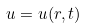<formula> <loc_0><loc_0><loc_500><loc_500>u = u ( r , t )</formula> 